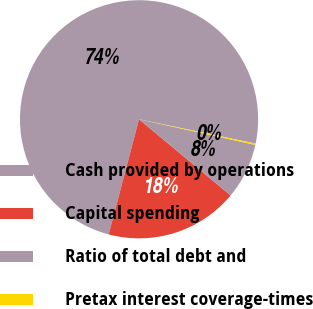<chart> <loc_0><loc_0><loc_500><loc_500><pie_chart><fcel>Cash provided by operations<fcel>Capital spending<fcel>Ratio of total debt and<fcel>Pretax interest coverage-times<nl><fcel>74.16%<fcel>18.07%<fcel>7.58%<fcel>0.19%<nl></chart> 